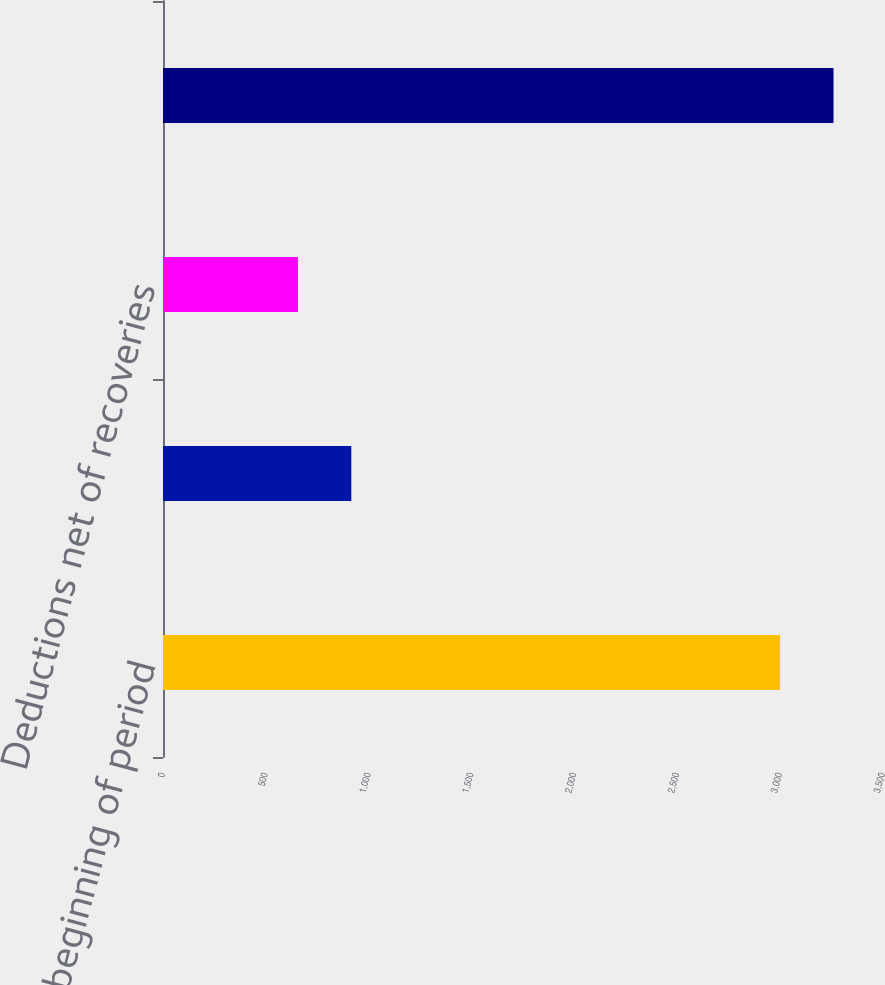Convert chart. <chart><loc_0><loc_0><loc_500><loc_500><bar_chart><fcel>Balance beginning of period<fcel>Additions to allowance<fcel>Deductions net of recoveries<fcel>Balance end of period<nl><fcel>3000<fcel>915.4<fcel>656<fcel>3259.4<nl></chart> 